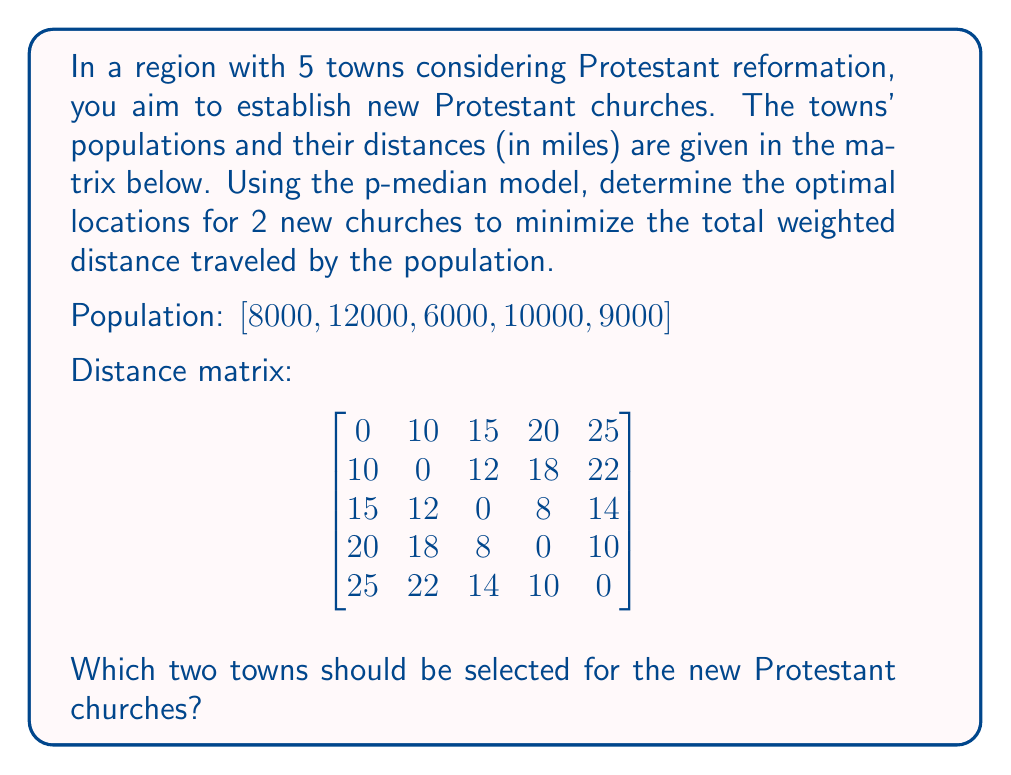Help me with this question. To solve this p-median problem, we need to:

1. Calculate the weighted distances for each possible combination of two towns.
2. Choose the combination with the lowest total weighted distance.

Let's go through each combination:

1. Towns 1 and 2:
   Total weighted distance = $(0 \cdot 8000 + 0 \cdot 12000 + 12 \cdot 6000 + 18 \cdot 10000 + 22 \cdot 9000) = 378,000$

2. Towns 1 and 3:
   Total weighted distance = $(0 \cdot 8000 + 10 \cdot 12000 + 0 \cdot 6000 + 8 \cdot 10000 + 14 \cdot 9000) = 326,000$

3. Towns 1 and 4:
   Total weighted distance = $(0 \cdot 8000 + 10 \cdot 12000 + 8 \cdot 6000 + 0 \cdot 10000 + 10 \cdot 9000) = 258,000$

4. Towns 1 and 5:
   Total weighted distance = $(0 \cdot 8000 + 10 \cdot 12000 + 14 \cdot 6000 + 10 \cdot 10000 + 0 \cdot 9000) = 304,000$

5. Towns 2 and 3:
   Total weighted distance = $(10 \cdot 8000 + 0 \cdot 12000 + 0 \cdot 6000 + 8 \cdot 10000 + 14 \cdot 9000) = 286,000$

6. Towns 2 and 4:
   Total weighted distance = $(10 \cdot 8000 + 0 \cdot 12000 + 8 \cdot 6000 + 0 \cdot 10000 + 10 \cdot 9000) = 218,000$

7. Towns 2 and 5:
   Total weighted distance = $(10 \cdot 8000 + 0 \cdot 12000 + 12 \cdot 6000 + 10 \cdot 10000 + 0 \cdot 9000) = 272,000$

8. Towns 3 and 4:
   Total weighted distance = $(15 \cdot 8000 + 12 \cdot 12000 + 0 \cdot 6000 + 0 \cdot 10000 + 10 \cdot 9000) = 294,000$

9. Towns 3 and 5:
   Total weighted distance = $(15 \cdot 8000 + 12 \cdot 12000 + 0 \cdot 6000 + 8 \cdot 10000 + 0 \cdot 9000) = 324,000$

10. Towns 4 and 5:
    Total weighted distance = $(20 \cdot 8000 + 18 \cdot 12000 + 8 \cdot 6000 + 0 \cdot 10000 + 0 \cdot 9000) = 408,000$

The combination with the lowest total weighted distance is Towns 2 and 4, with a total weighted distance of 218,000.
Answer: The optimal locations for the two new Protestant churches are Towns 2 and 4. 